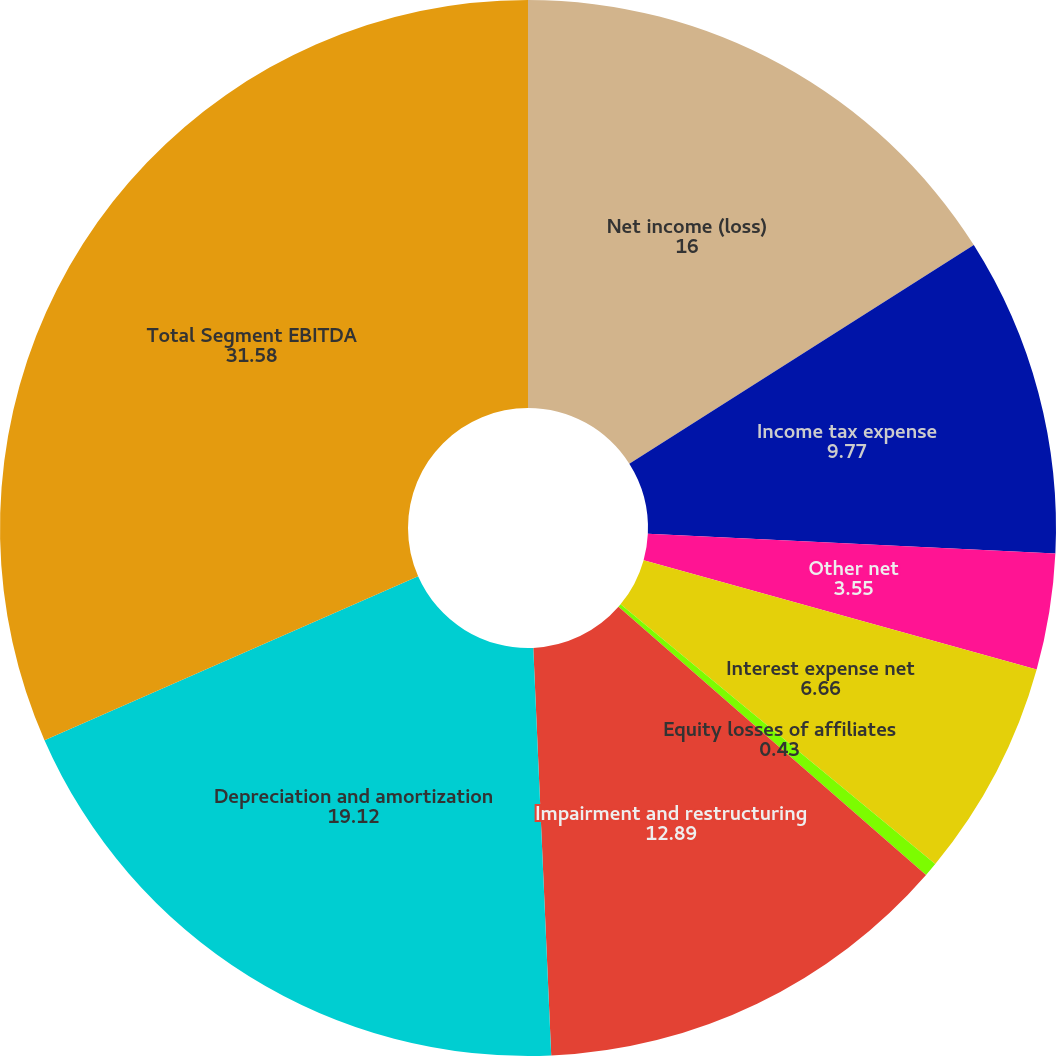Convert chart to OTSL. <chart><loc_0><loc_0><loc_500><loc_500><pie_chart><fcel>Net income (loss)<fcel>Income tax expense<fcel>Other net<fcel>Interest expense net<fcel>Equity losses of affiliates<fcel>Impairment and restructuring<fcel>Depreciation and amortization<fcel>Total Segment EBITDA<nl><fcel>16.0%<fcel>9.77%<fcel>3.55%<fcel>6.66%<fcel>0.43%<fcel>12.89%<fcel>19.12%<fcel>31.58%<nl></chart> 